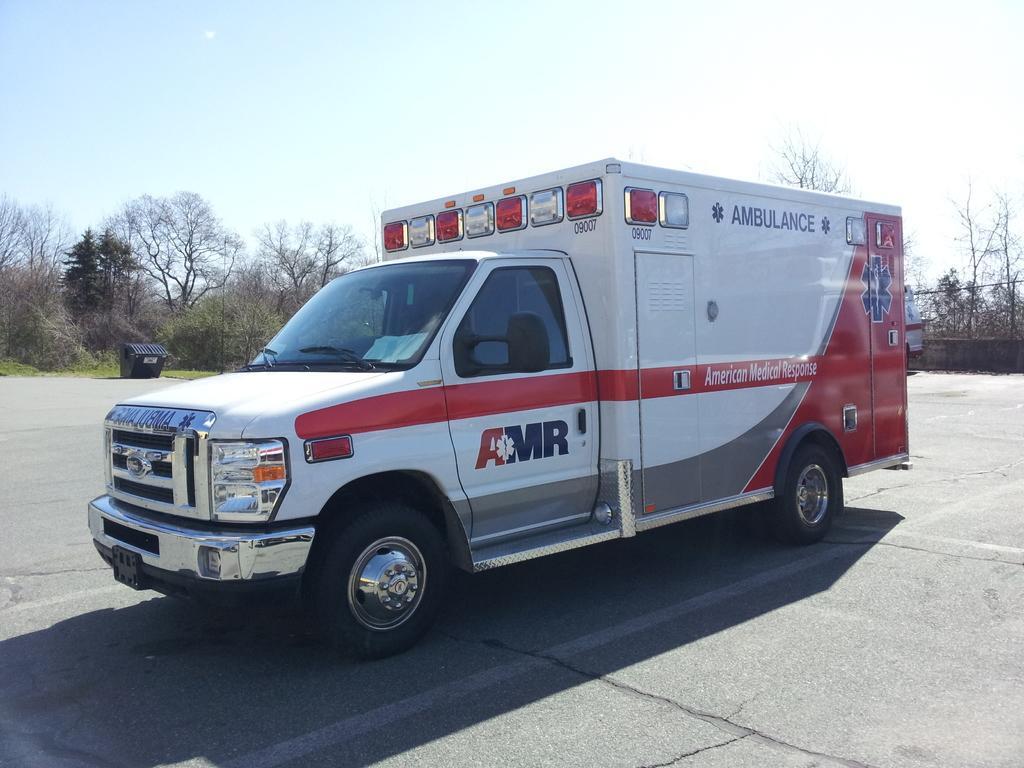Could you give a brief overview of what you see in this image? In the foreground of this image, there is an ambulance on the ground. In the background, there is a dustbin, grass, trees, the sky and the fencing. 